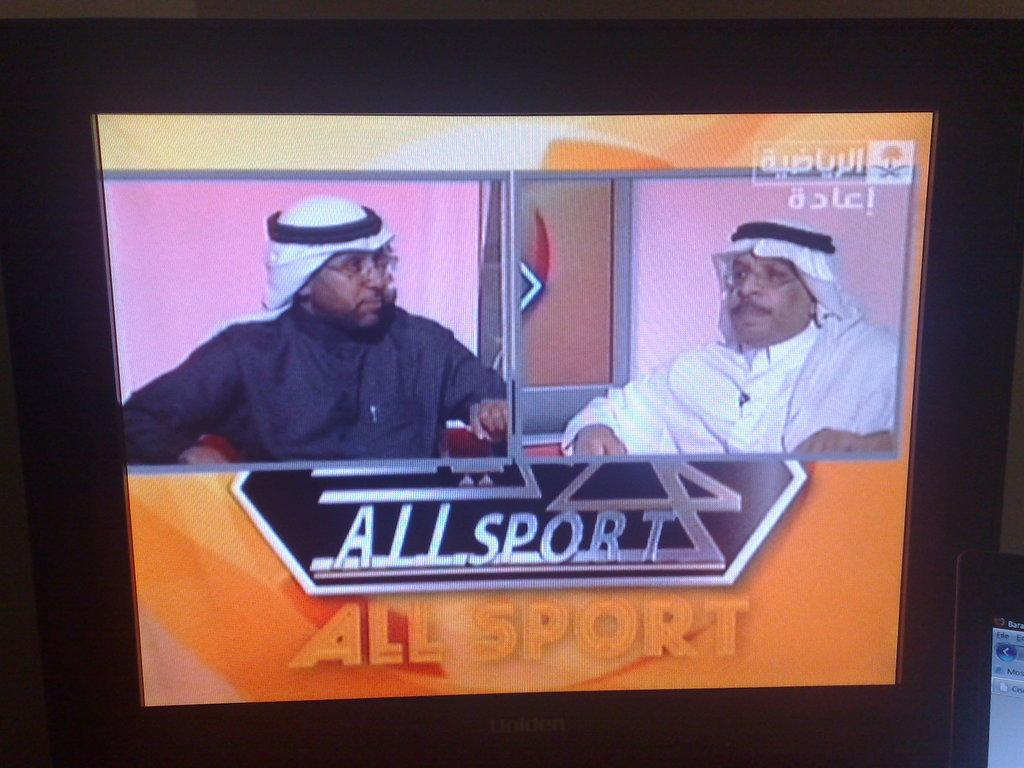<image>
Summarize the visual content of the image. Two people shown in split screen on a program called Allsport. 